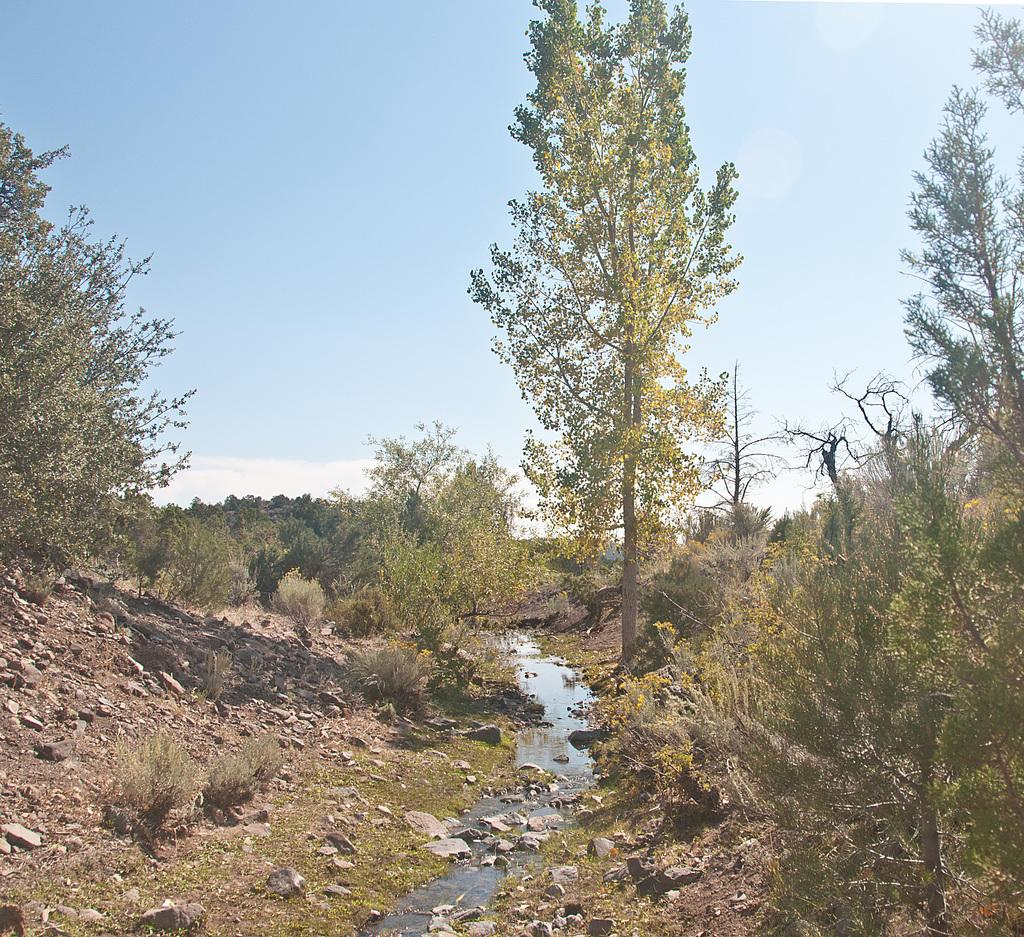What is visible on the ground in the image? The ground is visible in the image, and there are stones and grass present on it. What type of vegetation can be seen in the image? Plants and trees are visible in the image. Can you describe the water in the image? There is water visible in the image. What is visible in the sky in the image? The sky is visible in the image, and clouds are present in it. What scent can be detected from the dad in the image? There is no dad present in the image, so it is not possible to detect any scent from him. 